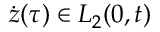<formula> <loc_0><loc_0><loc_500><loc_500>\dot { z } ( \tau ) \in L _ { 2 } ( 0 , t )</formula> 